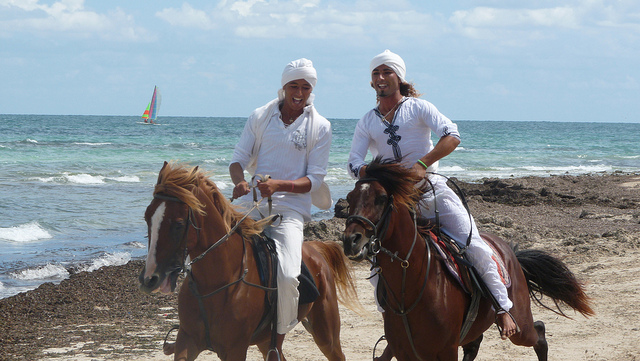Why are they so close together? They are close together likely because they are having a conversation and enjoying their time riding horses on the beach together. Sharing the experience with a friend can make it more enjoyable and memorable. 